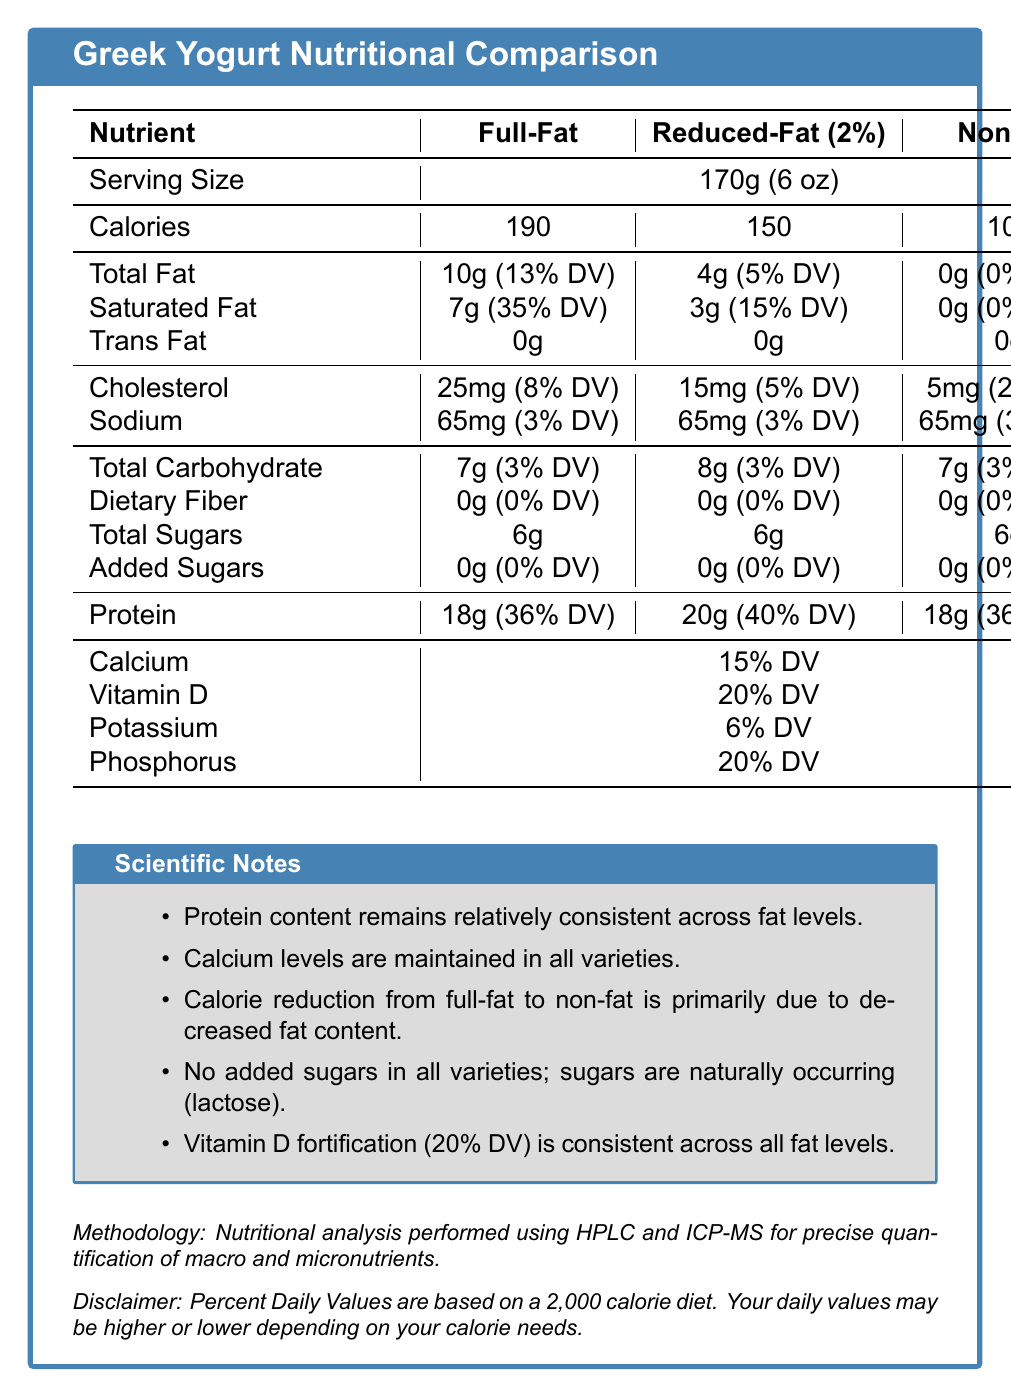What is the serving size for all the varieties of Greek yogurt? The document specifies the serving size as 170g (6 oz) for all three varieties under the "Serving Size" row.
Answer: 170g (6 oz) How many calories are in a serving of full-fat Greek yogurt? The table shows that a serving of full-fat Greek yogurt contains 190 calories.
Answer: 190 calories What is the total fat content in reduced-fat Greek yogurt? The total fat content for reduced-fat Greek yogurt is listed as 4 grams in the document.
Answer: 4 grams What is the daily value percentage of saturated fat in non-fat Greek yogurt? The saturated fat content for non-fat Greek yogurt is given as 0 grams, which corresponds to 0% of the daily value.
Answer: 0% How much protein is in all varieties of Greek yogurt? Protein content for full-fat, reduced-fat, and non-fat Greek yogurt is 18 grams, 20 grams, and 18 grams, respectively.
Answer: Full-Fat: 18g, Reduced-Fat: 20g, Non-Fat: 18g Which type of Greek yogurt has the highest cholesterol content? A. Full-Fat B. Reduced-Fat C. Non-Fat Full-fat Greek yogurt has 25 milligrams of cholesterol, which is higher than the 15 milligrams in reduced-fat and the 5 milligrams in non-fat varieties.
Answer: A What is the consistent vitamin D daily value percentage across all yogurt varieties? The scientific notes section states that the vitamin D fortification (20% DV) is consistent across all varieties.
Answer: 20% True or False: All varieties of Greek yogurt have added sugars. The document states that all varieties have 0 grams of added sugars.
Answer: False Summarize the main idea of the document. The main idea of the document is to compare the nutritional content of different types of Greek yogurt and provide information about their nutritional benefits, particularly in terms of protein, vitamins, and the lack of added sugars.
Answer: The document provides a comparative nutritional analysis of full-fat, reduced-fat, and non-fat Greek yogurt varieties, highlighting differences in calorie, fat, protein, and vitamin content. It includes detailed nutrient information, scientific notes, and the methodology used for analysis, emphasizing that Greek yogurt remains a high-protein food regardless of fat content, with no added sugars and consistent vitamin D fortification. What measurement method was used to quantify macro and micronutrients? The method for nutritional analysis was high-performance liquid chromatography (HPLC) and inductively coupled plasma mass spectrometry (ICP-MS).
Answer: HPLC and ICP-MS Can you determine the specific vitamin A content from the document? The document does not provide any specific details regarding the vitamin A content in any of the Greek yogurt varieties.
Answer: Not enough information 